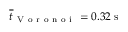<formula> <loc_0><loc_0><loc_500><loc_500>\overline { t } _ { V o r o n o i } = 0 . 3 2 \, s</formula> 